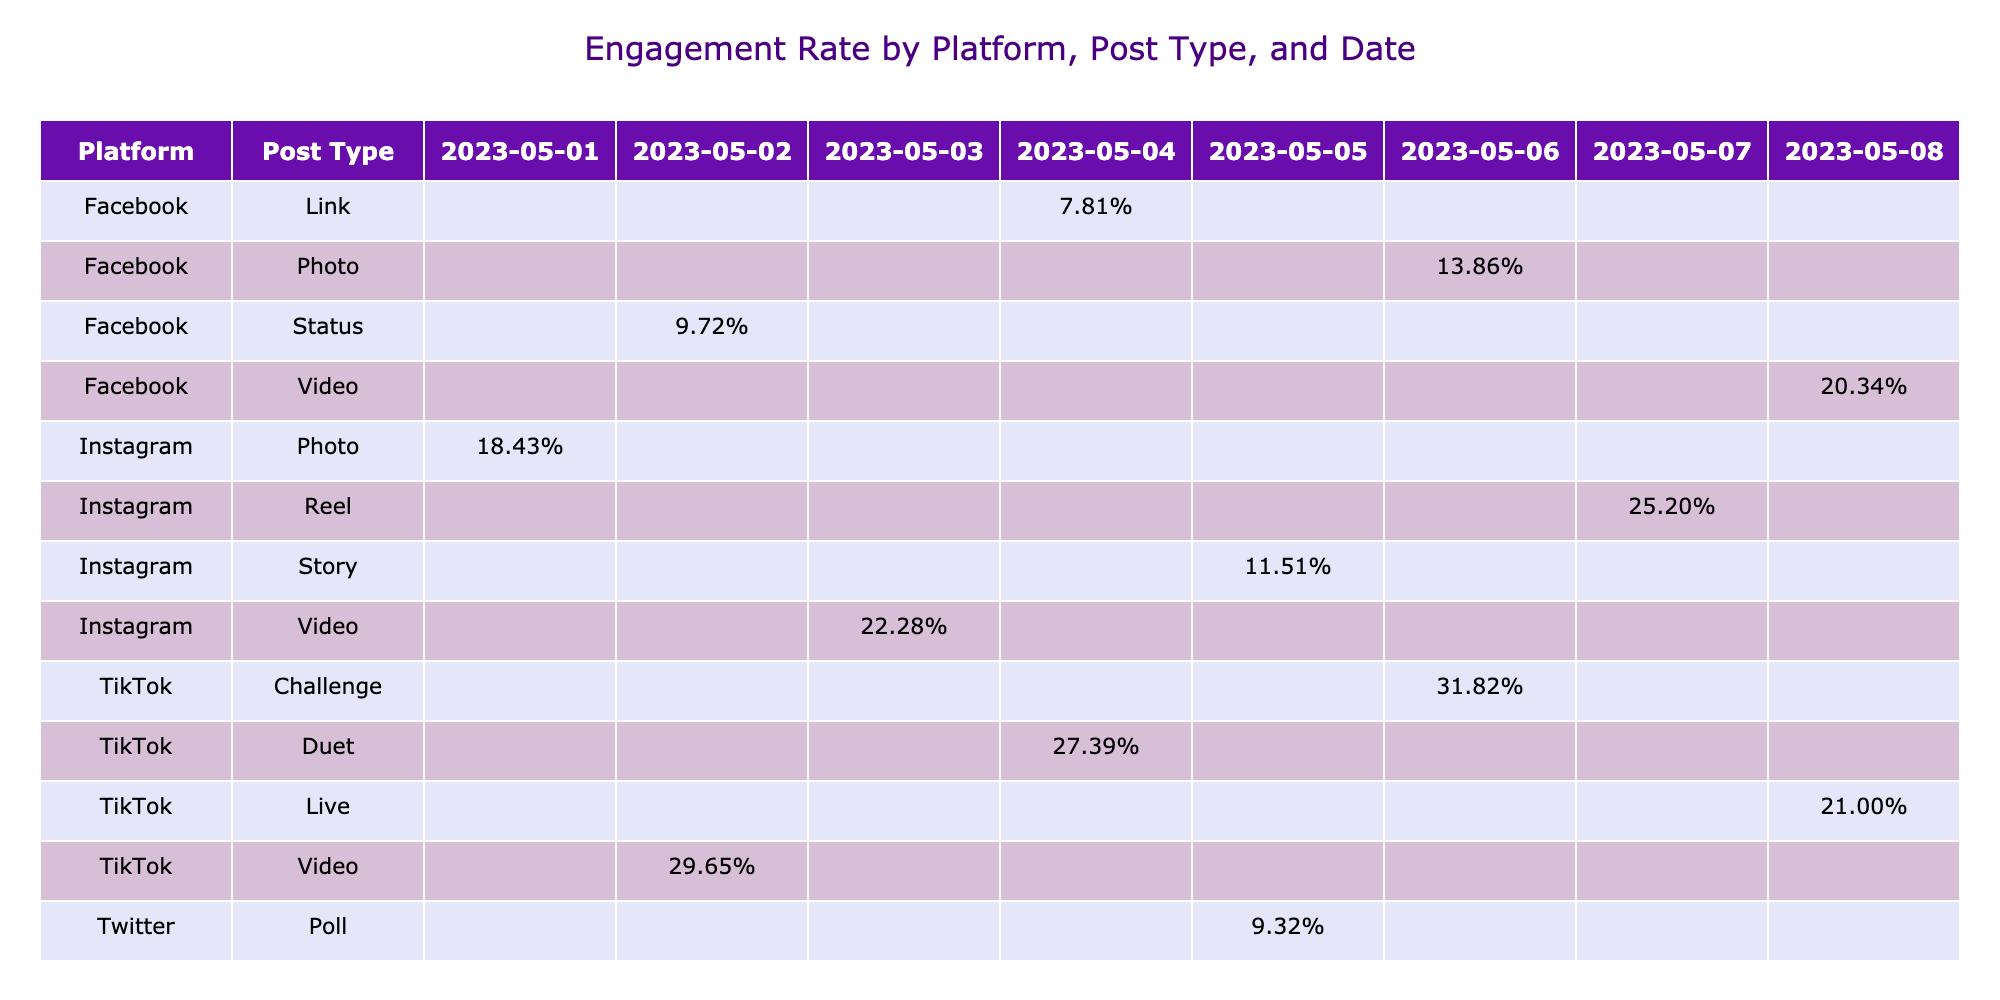What was the engagement rate of the TikTok Challenge on May 6, 2023? Looking at the table, locate the row for TikTok and the Post Type "Challenge." The engagement rate for that specific date is displayed in the corresponding cell, which shows 31.82%.
Answer: 31.82% Which platform had the highest engagement rate for Reels on May 7, 2023? Reviewing the table for Reels on May 7, the only entry found is for Instagram, which has an engagement rate of 25.20%. Therefore, it is the highest for that post type on that date.
Answer: Instagram Is the engagement rate for Facebook posts generally higher than that for Twitter posts? Analyzing the averages: the Facebook engagement rates are 9.72%, 7.81%, 13.86%, and 20.34%, averaging around 12.43%. The Twitter posts have rates of 7.90%, 7.46%, 9.32%, and 10.00%, averaging around 8.92%. Since 12.43% is greater than 8.92%, the answer is yes.
Answer: Yes What is the total number of Likes for all Instagram posts? In the table, sum the Likes for all Instagram posts: 15200 (Photo) + 22500 (Video) + 8900 (Story) + 31000 (Reel) = 77600. Therefore, the total Likes are 77600.
Answer: 77600 On which date did the TikTok videos achieve the highest engagement rate? Review the engagement rates for TikTok videos: May 2 (29.65%), May 4 (27.39%), May 6 (31.82%), and May 8 (21.00%). The highest engagement rate is on May 6 with 31.82%.
Answer: May 6, 2023 Was the engagement rate higher for the TikTok Live compared to the Instagram Story? The engagement rate for TikTok Live on May 8 is 21.00%, while for the Instagram Story on May 5, it is 11.51%. Since 21.00% is greater than 11.51%, the answer is yes.
Answer: Yes Which post type on Facebook had the lowest engagement rate? Look through the Facebook post types: Status (9.72%), Link (7.81%), Photo (13.86%), and Video (20.34%). The Link post type has the lowest engagement rate of 7.81%.
Answer: Link What is the average engagement rate for each platform? Calculate the average for each platform: For Instagram, the rates are 18.43%, 22.28%, 11.51%, and 25.20%, totaling 77.42%, which averages about 19.36%. For Facebook, the rates are 9.72%, 7.81%, 13.86%, and 20.34%, totaling 51.73%, averaging 12.93%. For Twitter, the rates total 34.68%, averaging 8.67%. For TikTok, the rates total 108.04%, averaging 27.01%. Therefore, the averages are approximately 19.36% for Instagram, 12.93% for Facebook, 8.67% for Twitter, and 27.01% for TikTok.
Answer: Instagram: 19.36%, Facebook: 12.93%, Twitter: 8.67%, TikTok: 27.01% 